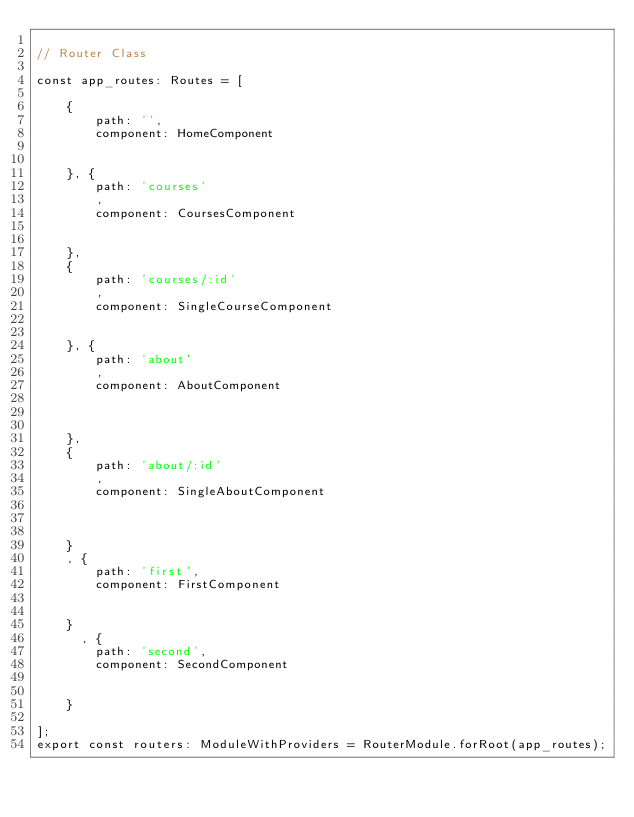<code> <loc_0><loc_0><loc_500><loc_500><_TypeScript_>
// Router Class 

const app_routes: Routes = [

    {
        path: '',
        component: HomeComponent


    }, {
        path: 'courses'
        ,
        component: CoursesComponent


    }, 
    {
        path: 'courses/:id'
        ,
        component: SingleCourseComponent


    }, {
        path: 'about'
        ,
        component: AboutComponent



    },
    {
        path: 'about/:id'
        ,
        component: SingleAboutComponent



    }
    , {
        path: 'first',
        component: FirstComponent


    }
      , {
        path: 'second',
        component: SecondComponent


    }

];
export const routers: ModuleWithProviders = RouterModule.forRoot(app_routes);

</code> 